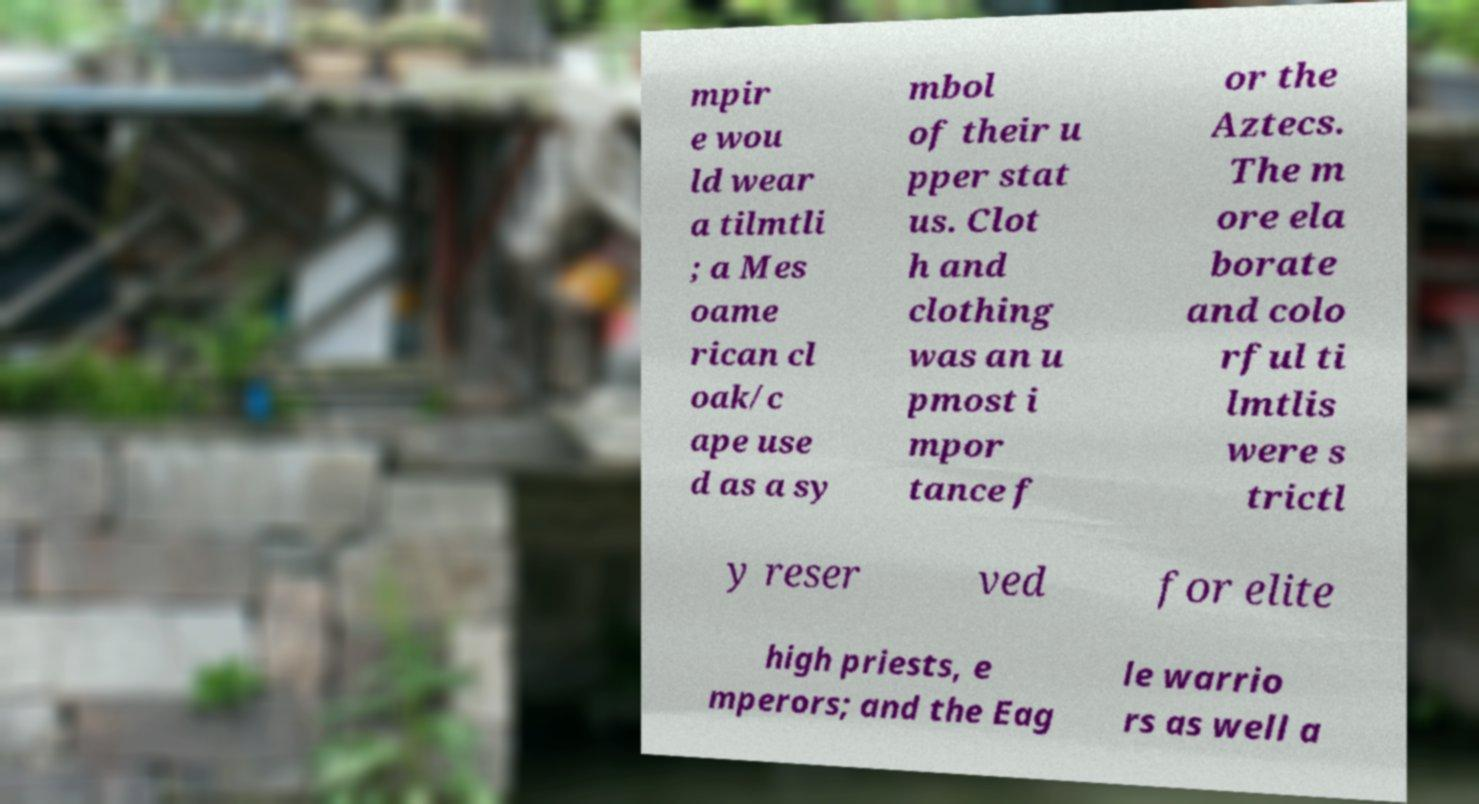Please read and relay the text visible in this image. What does it say? mpir e wou ld wear a tilmtli ; a Mes oame rican cl oak/c ape use d as a sy mbol of their u pper stat us. Clot h and clothing was an u pmost i mpor tance f or the Aztecs. The m ore ela borate and colo rful ti lmtlis were s trictl y reser ved for elite high priests, e mperors; and the Eag le warrio rs as well a 